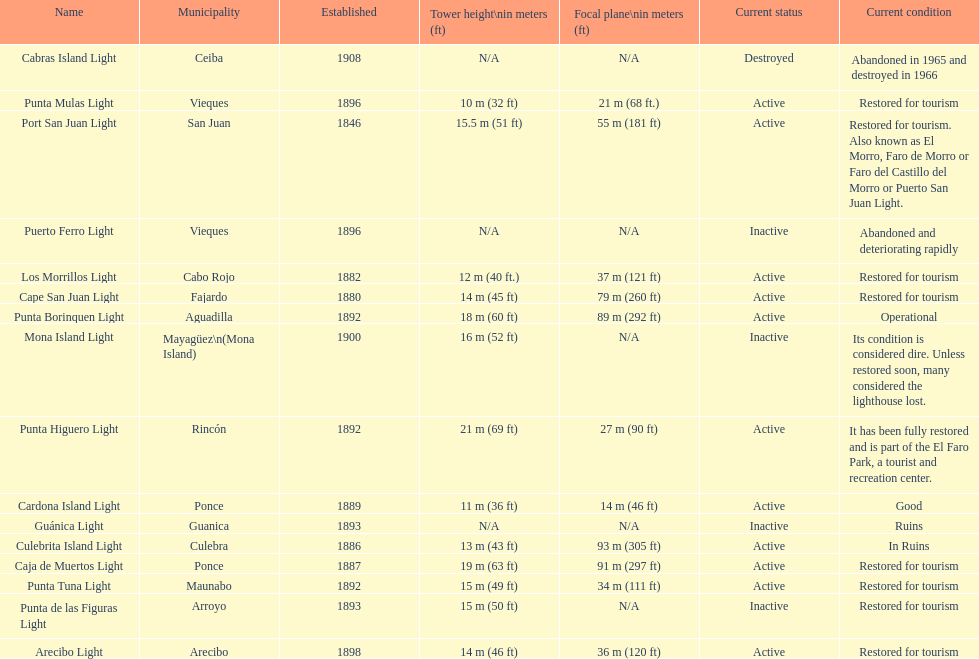Cardona island light and caja de muertos light are both located in what municipality? Ponce. 